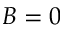Convert formula to latex. <formula><loc_0><loc_0><loc_500><loc_500>B = 0</formula> 